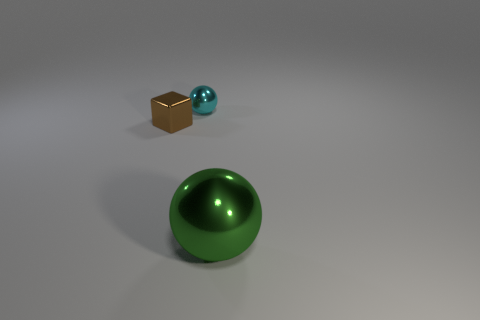The large sphere is what color?
Your response must be concise. Green. There is a metal thing that is to the right of the brown cube and in front of the cyan metallic ball; what is its color?
Your answer should be very brief. Green. There is a tiny thing that is to the left of the shiny sphere that is behind the shiny thing that is in front of the small metal cube; what color is it?
Your response must be concise. Brown. What color is the metallic sphere that is the same size as the metal cube?
Your answer should be very brief. Cyan. There is a object behind the tiny metal object left of the sphere behind the large green object; what is its shape?
Ensure brevity in your answer.  Sphere. What number of objects are either big blue rubber things or things in front of the small brown shiny object?
Make the answer very short. 1. There is a metallic object that is behind the block; does it have the same size as the metallic cube?
Provide a succinct answer. Yes. Are there the same number of small brown cubes behind the tiny brown thing and objects in front of the small sphere?
Offer a very short reply. No. There is another thing that is the same shape as the small cyan object; what color is it?
Your answer should be compact. Green. What number of matte things are large green objects or small objects?
Give a very brief answer. 0. 